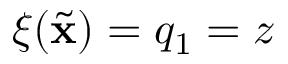Convert formula to latex. <formula><loc_0><loc_0><loc_500><loc_500>\xi ( { { \widetilde { x } } } ) = q _ { 1 } = z</formula> 